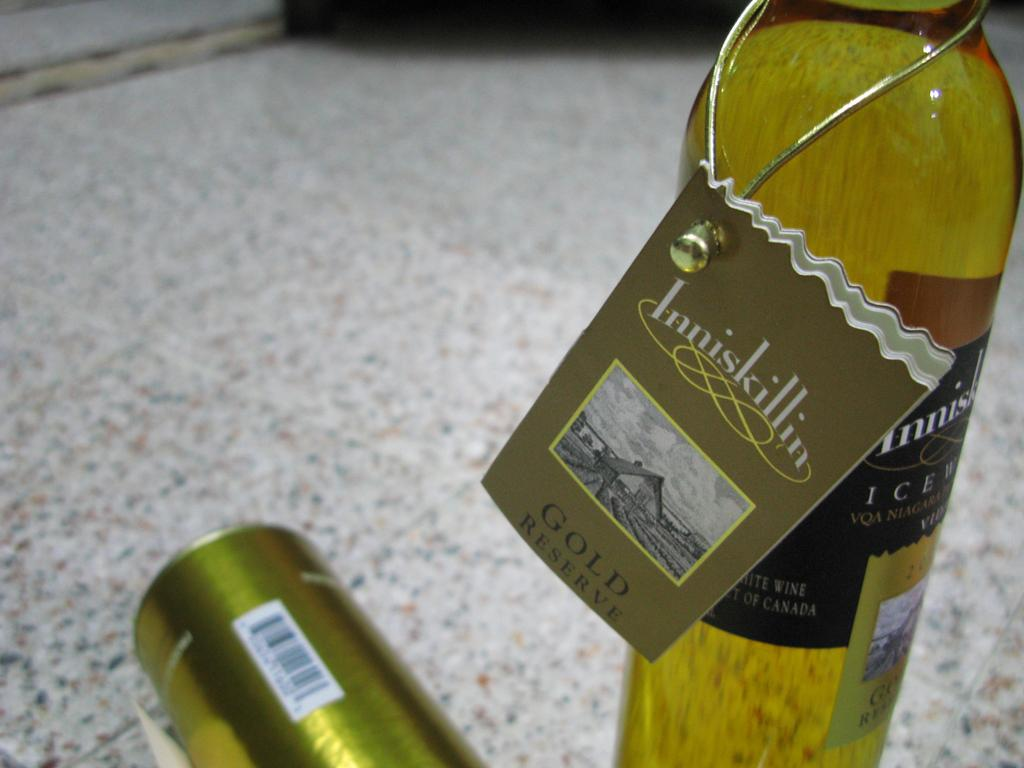What object is located on the right side of the image? There is a bottle on the right side of the image. What feature does the bottle have? The bottle has a label. What can be found on the label of the bottle? The label contains text. Where is the tin located in the image? The tin is in the bottom left of the image. How many pets can be seen in the image? There are no pets visible in the image. What direction are the men facing in the image? There are no men present in the image. 